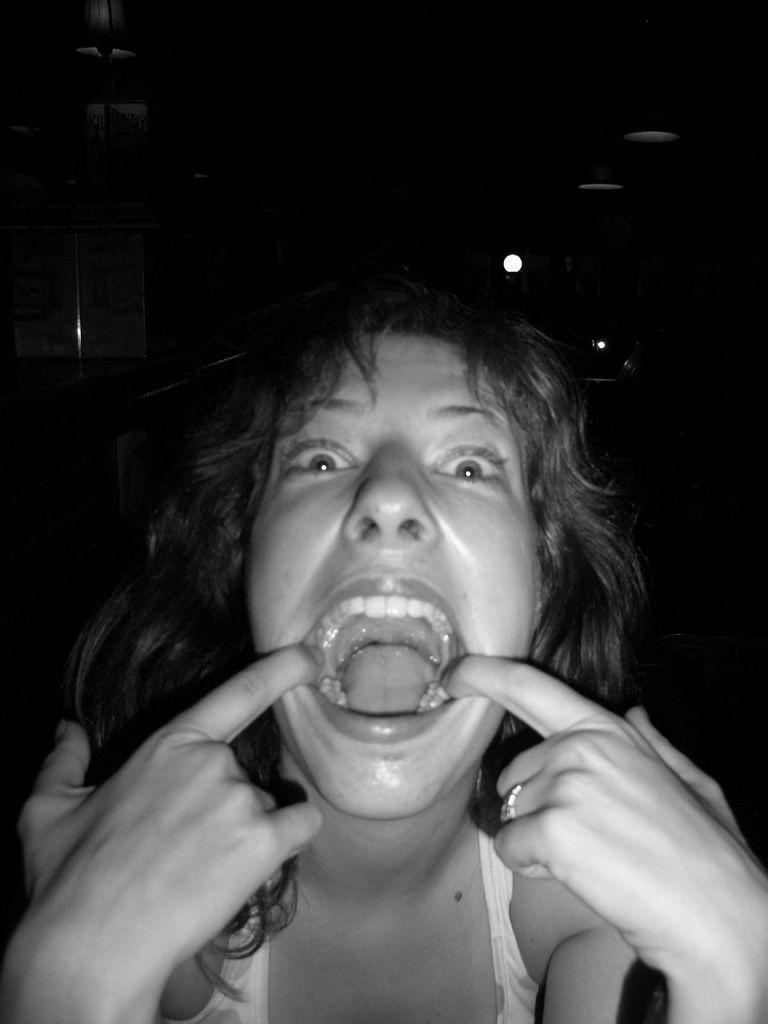Please provide a concise description of this image. In this black and white picture there is a woman. Top of the image there are lights. 